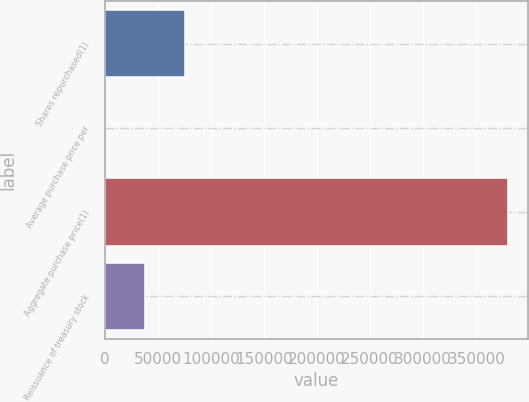<chart> <loc_0><loc_0><loc_500><loc_500><bar_chart><fcel>Shares repurchased(1)<fcel>Average purchase price per<fcel>Aggregate purchase price(1)<fcel>Reissuance of treasury stock<nl><fcel>76056.2<fcel>70.21<fcel>380000<fcel>38063.2<nl></chart> 